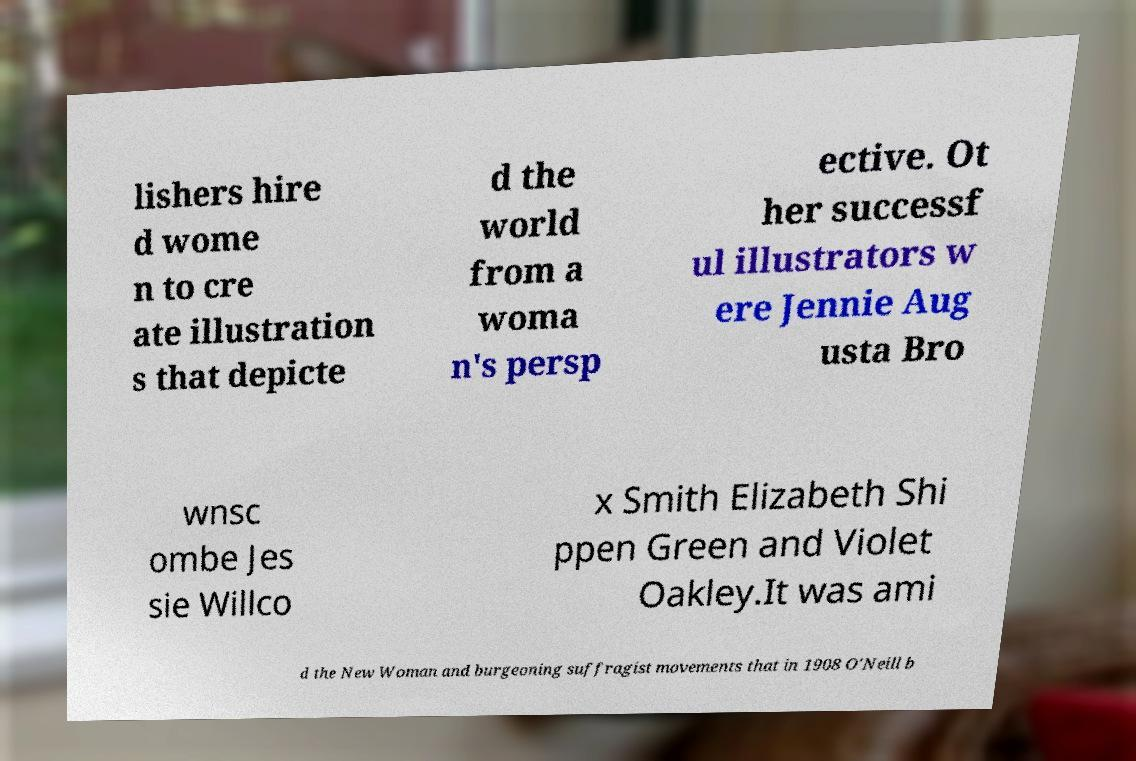I need the written content from this picture converted into text. Can you do that? lishers hire d wome n to cre ate illustration s that depicte d the world from a woma n's persp ective. Ot her successf ul illustrators w ere Jennie Aug usta Bro wnsc ombe Jes sie Willco x Smith Elizabeth Shi ppen Green and Violet Oakley.It was ami d the New Woman and burgeoning suffragist movements that in 1908 O'Neill b 